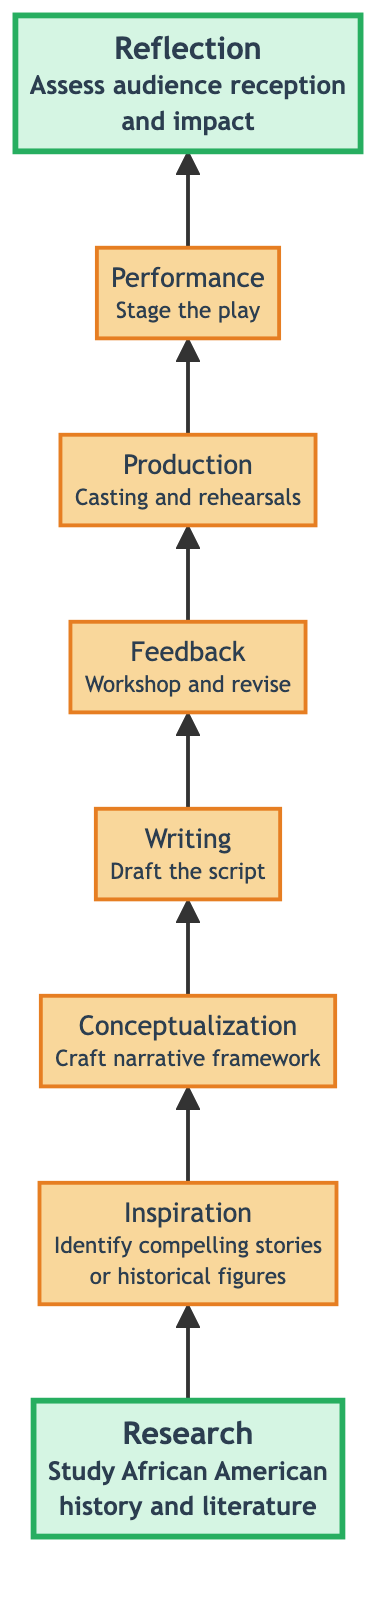What is the first step in the creative process? The diagram indicates that the first step is "Research," which involves an in-depth study of African American history and literature.
Answer: Research How many steps are there in the creative process? The diagram shows a total of eight distinct steps, from Research to Reflection.
Answer: 8 What comes after Writing in the creative process? Following the Writing step, the next step is "Feedback," which indicates the importance of workshopping and revising the script.
Answer: Feedback Which step emphasizes collaborative efforts? The "Feedback" step highlights the collaboration with actors, directors, and cultural consultants to refine the script.
Answer: Feedback What is the focus of the Performance step? The "Performance" step focuses on staging the play and bringing it to life in front of an audience.
Answer: Staging the play What are the two highlighted steps in the diagram? The steps highlighted in the diagram are "Research" (the first step) and "Reflection" (the last step), indicating their significance in the process.
Answer: Research and Reflection What key themes are outlined in the Conceptualization step? The Conceptualization step mentions key themes such as resilience, freedom, and cultural pride that are essential to the narrative.
Answer: Resilience, freedom, and cultural pride Which step directly assesses audience reception? The "Reflection" step assesses audience reception and the cultural impact of the play after it has been performed.
Answer: Reflection 